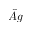<formula> <loc_0><loc_0><loc_500><loc_500>\hat { A } g</formula> 